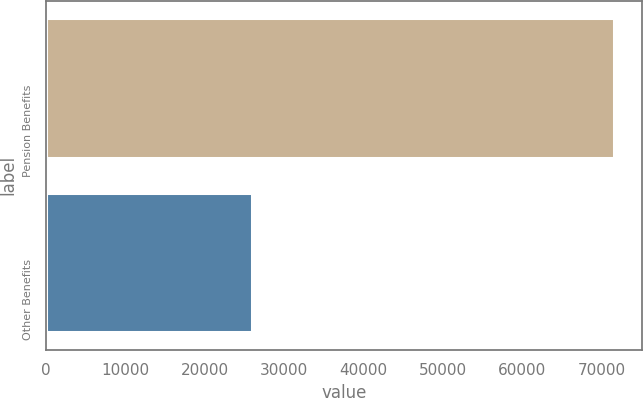<chart> <loc_0><loc_0><loc_500><loc_500><bar_chart><fcel>Pension Benefits<fcel>Other Benefits<nl><fcel>71544<fcel>25928<nl></chart> 